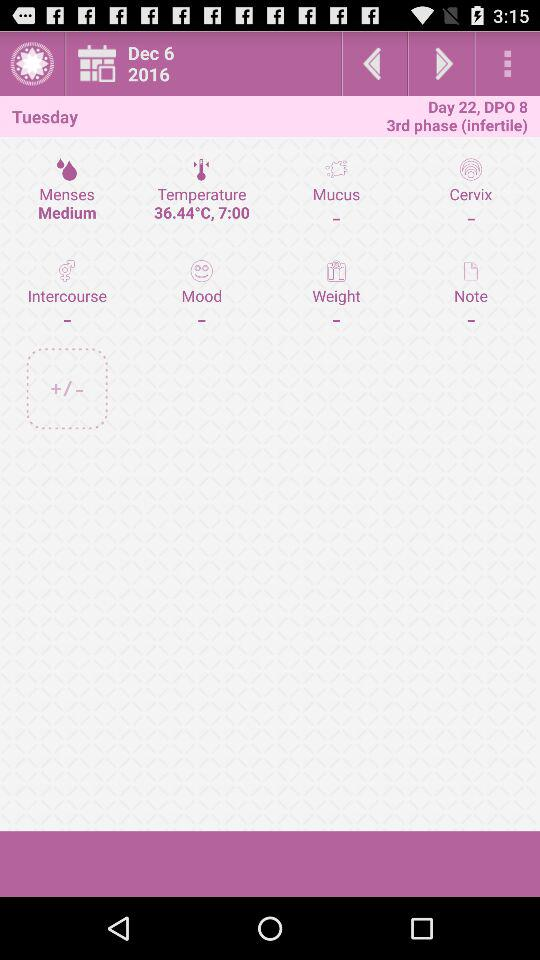What was the flow of menses? The flow of menses is medium. 